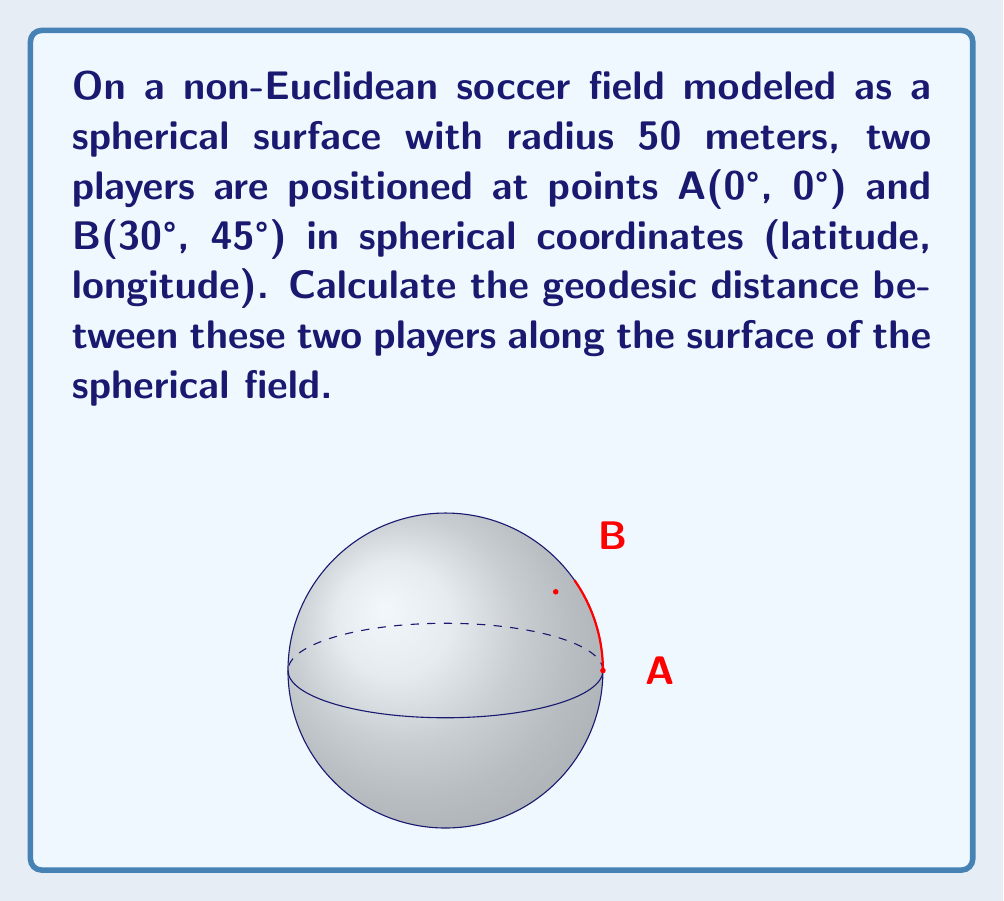Give your solution to this math problem. To solve this problem, we'll use the spherical law of cosines to find the central angle between the two points, then use that angle to calculate the arc length (geodesic distance) on the sphere's surface.

Step 1: Convert the coordinates to radians
A: (0°, 0°) = (0, 0) radians
B: (30°, 45°) = ($\frac{\pi}{6}$, $\frac{\pi}{4}$) radians

Step 2: Apply the spherical law of cosines
$$\cos(c) = \sin(a)\sin(b) + \cos(a)\cos(b)\cos(C)$$

Where:
a = latitude of A = 0
b = latitude of B = $\frac{\pi}{6}$
C = difference in longitude = $\frac{\pi}{4} - 0 = \frac{\pi}{4}$
c = central angle we're solving for

Substituting:
$$\cos(c) = \sin(0)\sin(\frac{\pi}{6}) + \cos(0)\cos(\frac{\pi}{6})\cos(\frac{\pi}{4})$$

$$\cos(c) = 0 + \cos(\frac{\pi}{6})\cos(\frac{\pi}{4})$$

$$\cos(c) = \frac{\sqrt{3}}{2} \cdot \frac{\sqrt{2}}{2} = \frac{\sqrt{6}}{4}$$

Step 3: Solve for c
$$c = \arccos(\frac{\sqrt{6}}{4}) \approx 0.841469 \text{ radians}$$

Step 4: Calculate the arc length (geodesic distance)
Arc length = radius × central angle
$$d = 50 \times 0.841469 \approx 42.07345 \text{ meters}$$
Answer: $42.07$ meters 